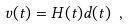Convert formula to latex. <formula><loc_0><loc_0><loc_500><loc_500>v ( t ) = H ( t ) d ( t ) \ ,</formula> 